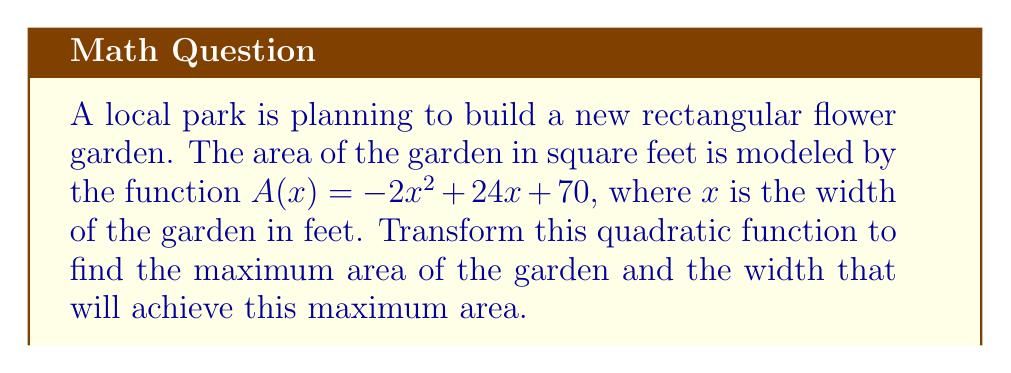Help me with this question. To find the maximum area and the corresponding width, we need to transform the quadratic function into vertex form. The vertex form of a quadratic function is $f(x) = a(x - h)^2 + k$, where $(h, k)$ is the vertex of the parabola.

Step 1: Identify the coefficients of the quadratic function.
$A(x) = -2x^2 + 24x + 70$
$a = -2$, $b = 24$, $c = 70$

Step 2: Calculate $h$ (the x-coordinate of the vertex) using the formula $h = -\frac{b}{2a}$.
$h = -\frac{24}{2(-2)} = -\frac{24}{-4} = 6$

Step 3: Calculate $k$ (the y-coordinate of the vertex) by substituting $x = h$ into the original function.
$k = A(6) = -2(6)^2 + 24(6) + 70$
$k = -2(36) + 144 + 70$
$k = -72 + 144 + 70 = 142$

Step 4: Write the function in vertex form.
$A(x) = -2(x - 6)^2 + 142$

The vertex $(h, k) = (6, 142)$ represents the maximum point of the parabola because $a$ is negative (the parabola opens downward).

Therefore, the maximum area of the garden is 142 square feet, and this occurs when the width is 6 feet.
Answer: Maximum area: 142 sq ft; Optimal width: 6 ft 